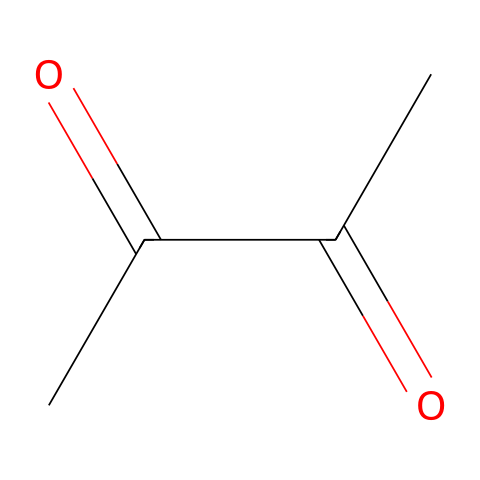What is the total number of carbon atoms in this chemical? The SMILES representation shows the arrangement of atoms. Each 'C' in the structure represents a carbon atom, and there are a total of three 'C's. Therefore, the total number of carbon atoms is 3.
Answer: 3 How many oxygen atoms are present in this chemical? The SMILES notation has 'O' indicated twice. Each 'O' represents an oxygen atom. Thus, there are a total of 2 oxygen atoms in the chemical structure.
Answer: 2 What type of functional group is present in this chemical? The SMILES shows the presence of 'C(=O)', indicating that there are carbonyl groups. The presence of two carbonyl groups (due to two 'C(=O)') suggests it could be categorized as a diketone.
Answer: diketone What is the common use of this chemical in food products? As a flavor enhancer, this chemical is widely recognized for its ability to improve taste and is commonly used in food products like microwave popcorn. This usage is related to its properties within the food additives category.
Answer: flavor enhancer Can this chemical be classified as a natural or synthetic additive? The chemical's characteristics and its common applications point towards it being a synthetic compound commonly used in food, particularly as a flavor enhancer.
Answer: synthetic 